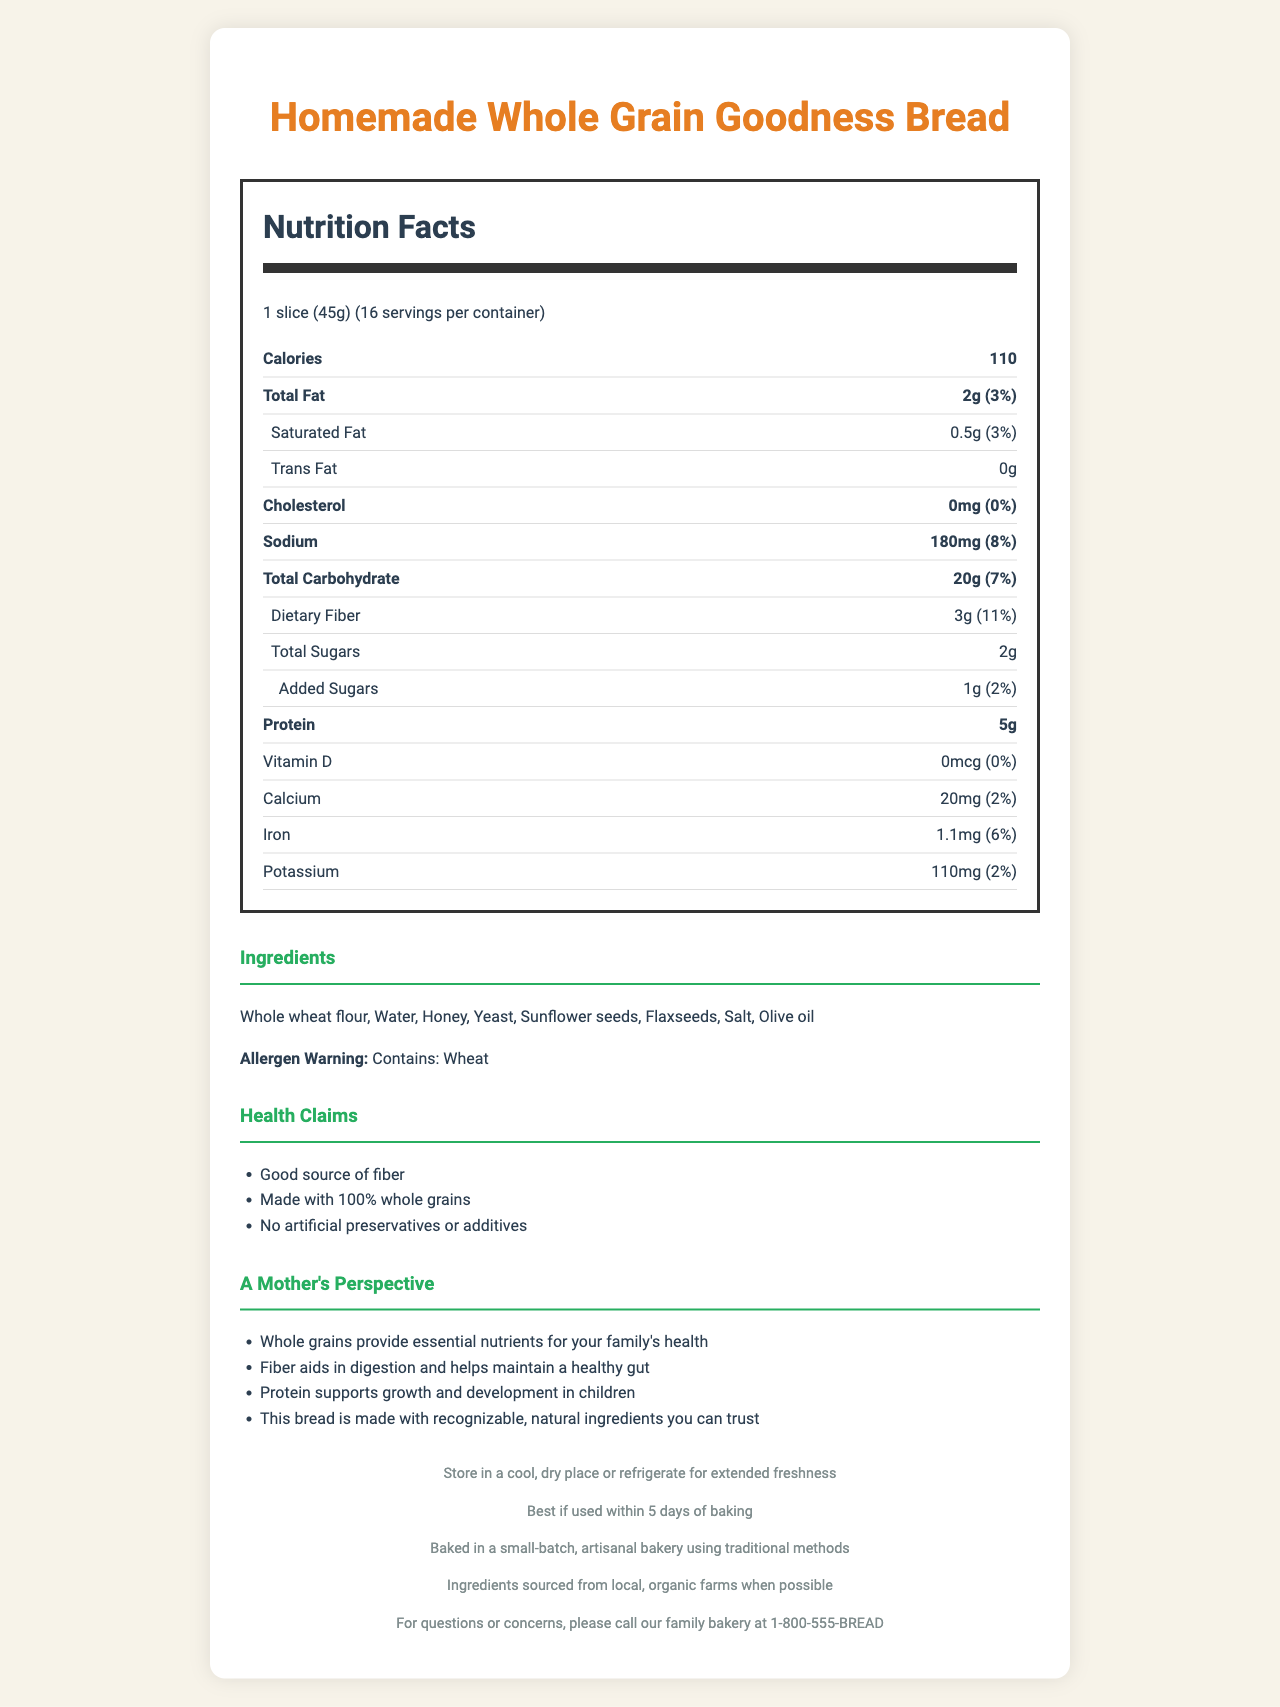what is the product name? The product name is explicitly mentioned at the top of the document.
Answer: Homemade Whole Grain Goodness Bread how many servings are in the container? It is stated under the "serving size" section as "16 servings per container".
Answer: 16 how much fiber is in one serving? The amount of dietary fiber per serving is listed as 3g in the Nutrition Facts section.
Answer: 3g What is the percent daily value for protein? The document lists the amount of protein but does not provide a percent daily value (%DV).
Answer: Not provided Can you list the ingredients? The ingredients section lists these items.
Answer: Whole wheat flour, Water, Honey, Yeast, Sunflower seeds, Flaxseeds, Salt, Olive oil What nutrient supports growth and development in children according to maternal advice? The maternal advice section mentions that "Protein supports growth and development in children".
Answer: Protein how many grams of total sugars are in one serving? The total sugars per serving are mentioned as 2g in the Nutrition Facts section.
Answer: 2g how much sodium does this bread contain per serving? The sodium content per serving is stated to be 180mg.
Answer: 180mg what is the expiration date of the bread? The expiration date note states this information.
Answer: Best if used within 5 days of baking What should you do to ensure the bread stays fresh for a longer time? A. Store in a cool, dry place B. Store in a warm place C. Store in a freezer The storage instructions in the footer of the document state to "Store in a cool, dry place or refrigerate for extended freshness".
Answer: A. Store in a cool, dry place which of these is not a health claim for this bread? A. Made with 100% whole grains B. Low in fat C. No artificial preservatives or additives The listed health claims are "Good source of fiber", "Made with 100% whole grains", and "No artificial preservatives or additives". "Low in fat" is not mentioned.
Answer: B. Low in fat Does this bread contain cholesterol? The Nutrition Facts section indicates 0mg cholesterol, equating to a 0% daily value.
Answer: No Summarize the main idea of the document. The document is comprehensive, including nutritional information like calories, fats, proteins, and fibers per serving, and it focuses on the wholesome nature of the ingredients and the benefits of the bread.
Answer: The document provides detailed Nutrition Facts, ingredients, health claims, maternal advice, and storage instructions for Homemade Whole Grain Goodness Bread, emphasizing its good fiber content, natural ingredients, and local, artisanal baking process. Is this bread certified gluten-free? The document does not provide any information regarding gluten content or certifications related to gluten. This cannot be determined from the provided information.
Answer: I don't know 